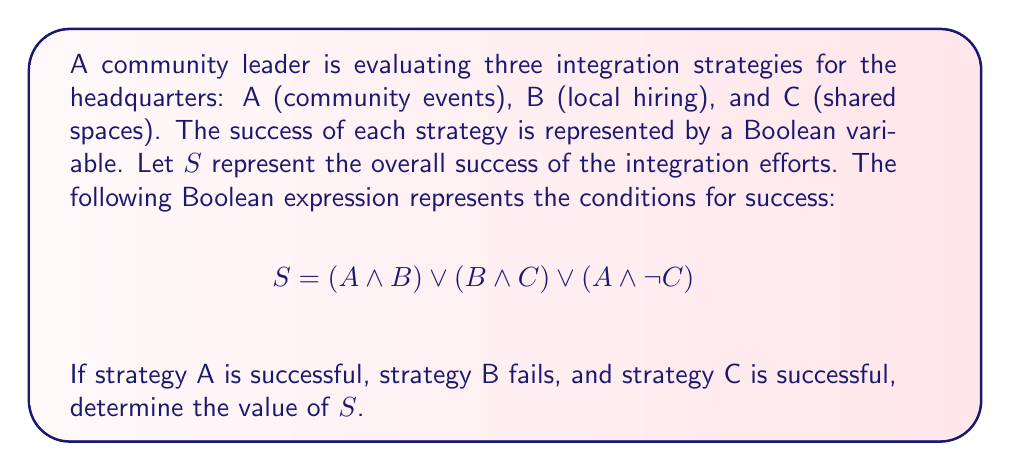Solve this math problem. Let's approach this step-by-step:

1) We're given that:
   A = 1 (successful)
   B = 0 (fails)
   C = 1 (successful)

2) Let's substitute these values into our Boolean expression:

   $S = (A \land B) \lor (B \land C) \lor (A \land \lnot C)$

3) Substituting the values:

   $S = (1 \land 0) \lor (0 \land 1) \lor (1 \land \lnot 1)$

4) Let's evaluate each part:

   $(1 \land 0) = 0$
   $(0 \land 1) = 0$
   $(1 \land \lnot 1) = (1 \land 0) = 0$

5) Now our expression looks like:

   $S = 0 \lor 0 \lor 0$

6) The logical OR ($\lor$) of any number of 0's is still 0.

Therefore, $S = 0$.
Answer: $S = 0$ 